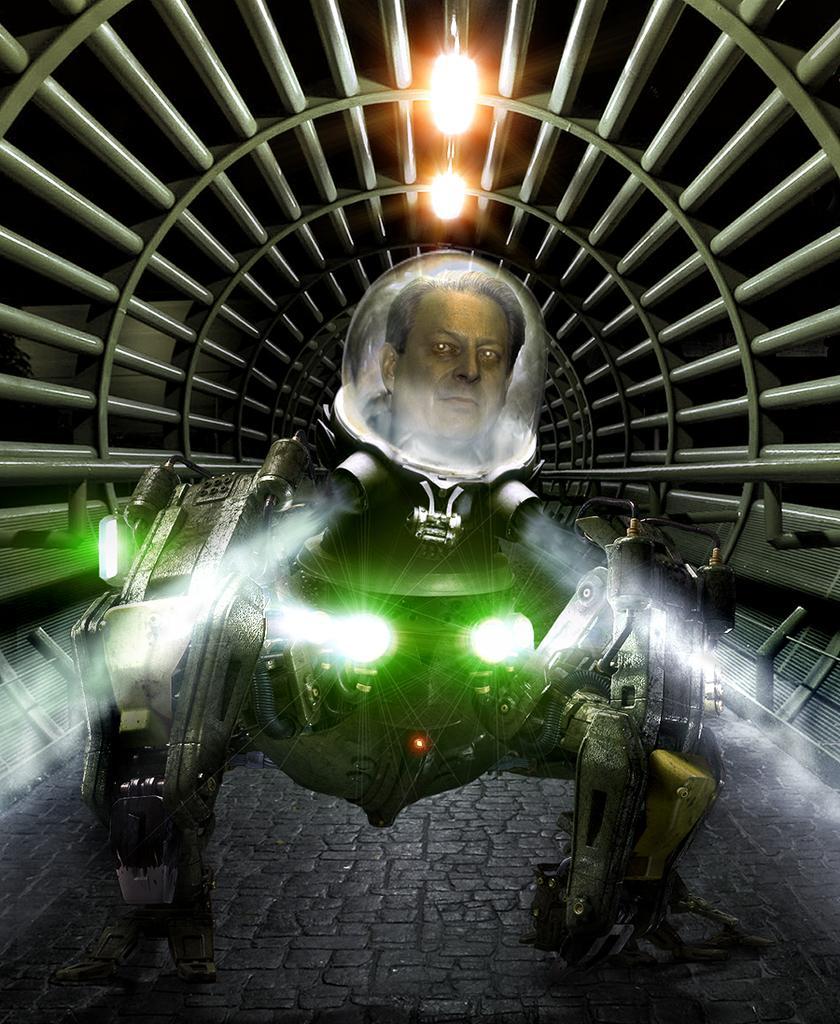Describe this image in one or two sentences. In this picture we can see an electronic machine and on this a human face is projected. And these are the lights. And this is the tunnel. 